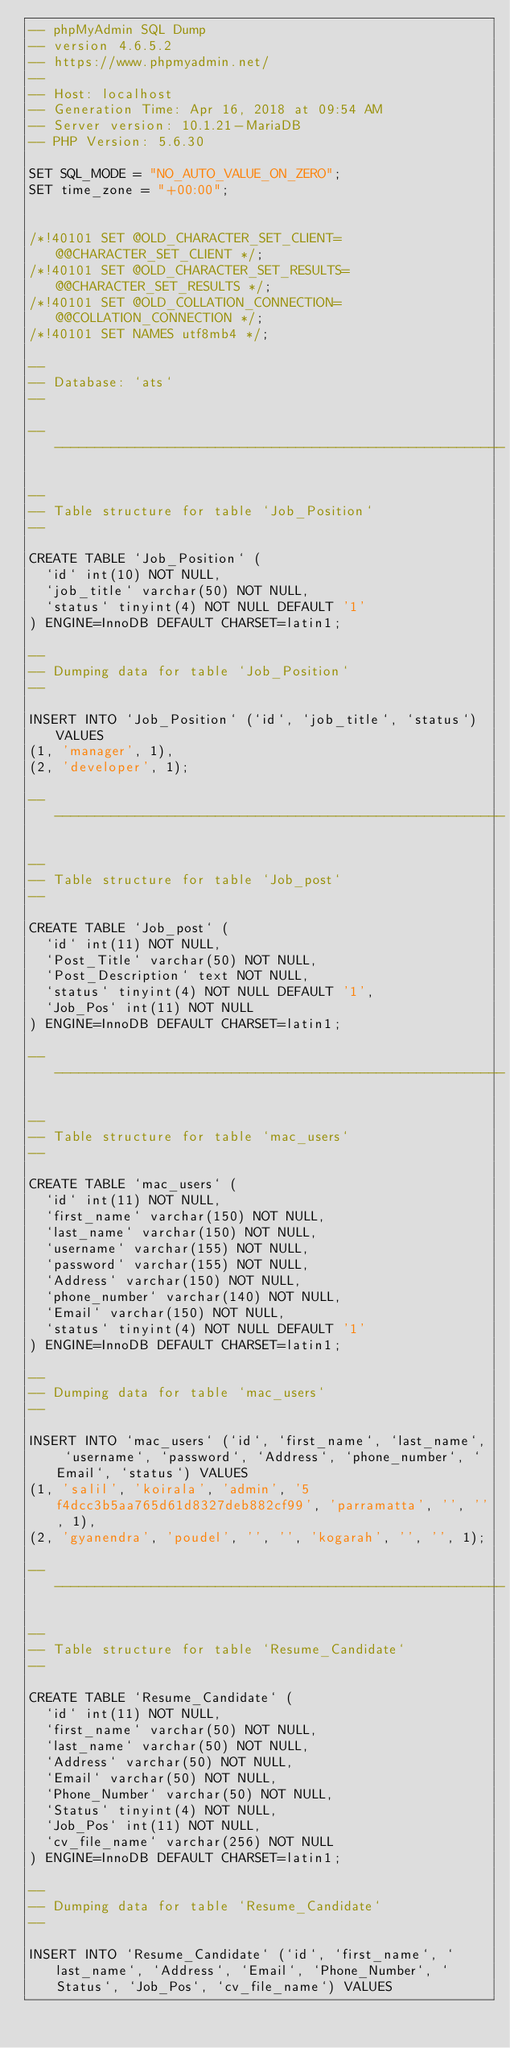<code> <loc_0><loc_0><loc_500><loc_500><_SQL_>-- phpMyAdmin SQL Dump
-- version 4.6.5.2
-- https://www.phpmyadmin.net/
--
-- Host: localhost
-- Generation Time: Apr 16, 2018 at 09:54 AM
-- Server version: 10.1.21-MariaDB
-- PHP Version: 5.6.30

SET SQL_MODE = "NO_AUTO_VALUE_ON_ZERO";
SET time_zone = "+00:00";


/*!40101 SET @OLD_CHARACTER_SET_CLIENT=@@CHARACTER_SET_CLIENT */;
/*!40101 SET @OLD_CHARACTER_SET_RESULTS=@@CHARACTER_SET_RESULTS */;
/*!40101 SET @OLD_COLLATION_CONNECTION=@@COLLATION_CONNECTION */;
/*!40101 SET NAMES utf8mb4 */;

--
-- Database: `ats`
--

-- --------------------------------------------------------

--
-- Table structure for table `Job_Position`
--

CREATE TABLE `Job_Position` (
  `id` int(10) NOT NULL,
  `job_title` varchar(50) NOT NULL,
  `status` tinyint(4) NOT NULL DEFAULT '1'
) ENGINE=InnoDB DEFAULT CHARSET=latin1;

--
-- Dumping data for table `Job_Position`
--

INSERT INTO `Job_Position` (`id`, `job_title`, `status`) VALUES
(1, 'manager', 1),
(2, 'developer', 1);

-- --------------------------------------------------------

--
-- Table structure for table `Job_post`
--

CREATE TABLE `Job_post` (
  `id` int(11) NOT NULL,
  `Post_Title` varchar(50) NOT NULL,
  `Post_Description` text NOT NULL,
  `status` tinyint(4) NOT NULL DEFAULT '1',
  `Job_Pos` int(11) NOT NULL
) ENGINE=InnoDB DEFAULT CHARSET=latin1;

-- --------------------------------------------------------

--
-- Table structure for table `mac_users`
--

CREATE TABLE `mac_users` (
  `id` int(11) NOT NULL,
  `first_name` varchar(150) NOT NULL,
  `last_name` varchar(150) NOT NULL,
  `username` varchar(155) NOT NULL,
  `password` varchar(155) NOT NULL,
  `Address` varchar(150) NOT NULL,
  `phone_number` varchar(140) NOT NULL,
  `Email` varchar(150) NOT NULL,
  `status` tinyint(4) NOT NULL DEFAULT '1'
) ENGINE=InnoDB DEFAULT CHARSET=latin1;

--
-- Dumping data for table `mac_users`
--

INSERT INTO `mac_users` (`id`, `first_name`, `last_name`, `username`, `password`, `Address`, `phone_number`, `Email`, `status`) VALUES
(1, 'salil', 'koirala', 'admin', '5f4dcc3b5aa765d61d8327deb882cf99', 'parramatta', '', '', 1),
(2, 'gyanendra', 'poudel', '', '', 'kogarah', '', '', 1);

-- --------------------------------------------------------

--
-- Table structure for table `Resume_Candidate`
--

CREATE TABLE `Resume_Candidate` (
  `id` int(11) NOT NULL,
  `first_name` varchar(50) NOT NULL,
  `last_name` varchar(50) NOT NULL,
  `Address` varchar(50) NOT NULL,
  `Email` varchar(50) NOT NULL,
  `Phone_Number` varchar(50) NOT NULL,
  `Status` tinyint(4) NOT NULL,
  `Job_Pos` int(11) NOT NULL,
  `cv_file_name` varchar(256) NOT NULL
) ENGINE=InnoDB DEFAULT CHARSET=latin1;

--
-- Dumping data for table `Resume_Candidate`
--

INSERT INTO `Resume_Candidate` (`id`, `first_name`, `last_name`, `Address`, `Email`, `Phone_Number`, `Status`, `Job_Pos`, `cv_file_name`) VALUES</code> 